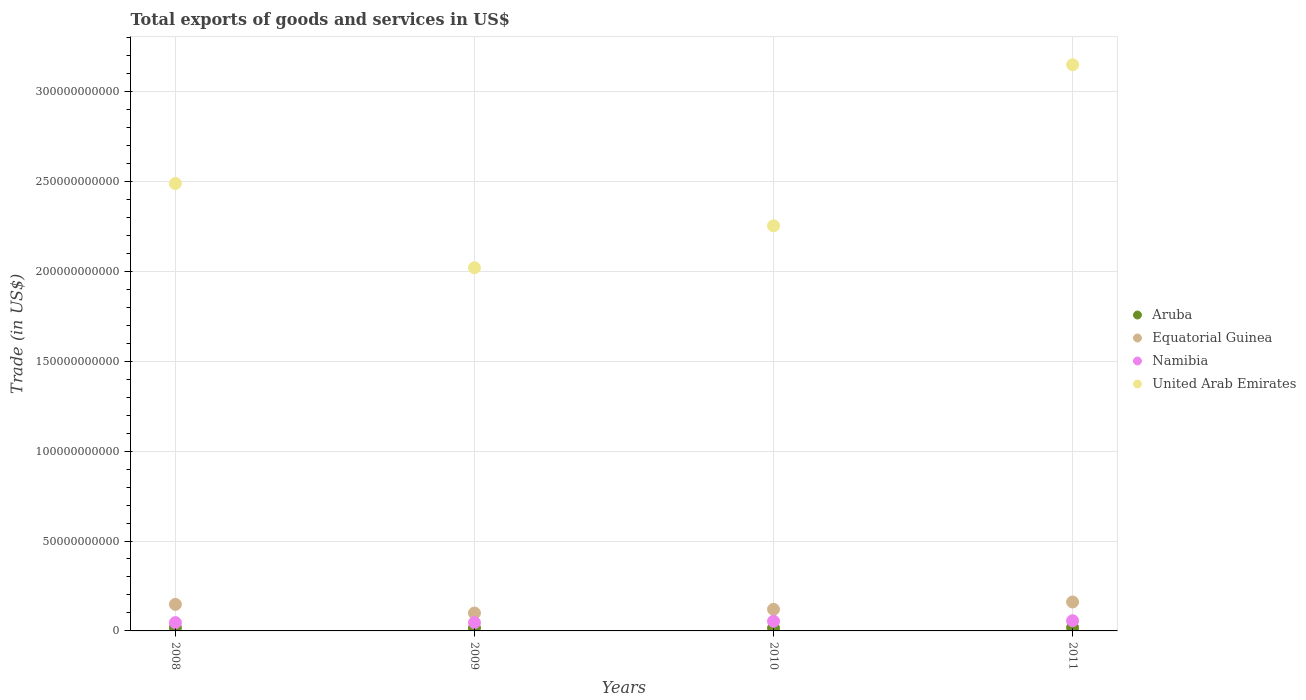What is the total exports of goods and services in Equatorial Guinea in 2010?
Your answer should be compact. 1.20e+1. Across all years, what is the maximum total exports of goods and services in Namibia?
Provide a succinct answer. 5.65e+09. Across all years, what is the minimum total exports of goods and services in Equatorial Guinea?
Provide a succinct answer. 9.96e+09. In which year was the total exports of goods and services in United Arab Emirates maximum?
Provide a succinct answer. 2011. What is the total total exports of goods and services in Namibia in the graph?
Your answer should be very brief. 2.03e+1. What is the difference between the total exports of goods and services in Equatorial Guinea in 2009 and that in 2011?
Offer a terse response. -6.13e+09. What is the difference between the total exports of goods and services in Aruba in 2011 and the total exports of goods and services in Namibia in 2008?
Your response must be concise. -2.78e+09. What is the average total exports of goods and services in United Arab Emirates per year?
Your response must be concise. 2.48e+11. In the year 2009, what is the difference between the total exports of goods and services in Equatorial Guinea and total exports of goods and services in United Arab Emirates?
Give a very brief answer. -1.92e+11. In how many years, is the total exports of goods and services in Equatorial Guinea greater than 90000000000 US$?
Your answer should be compact. 0. What is the ratio of the total exports of goods and services in Equatorial Guinea in 2009 to that in 2010?
Ensure brevity in your answer.  0.83. What is the difference between the highest and the second highest total exports of goods and services in Equatorial Guinea?
Offer a very short reply. 1.32e+09. What is the difference between the highest and the lowest total exports of goods and services in United Arab Emirates?
Offer a very short reply. 1.13e+11. In how many years, is the total exports of goods and services in Aruba greater than the average total exports of goods and services in Aruba taken over all years?
Offer a terse response. 2. Is it the case that in every year, the sum of the total exports of goods and services in Aruba and total exports of goods and services in United Arab Emirates  is greater than the total exports of goods and services in Equatorial Guinea?
Provide a succinct answer. Yes. Does the total exports of goods and services in United Arab Emirates monotonically increase over the years?
Offer a very short reply. No. Is the total exports of goods and services in United Arab Emirates strictly less than the total exports of goods and services in Equatorial Guinea over the years?
Make the answer very short. No. What is the difference between two consecutive major ticks on the Y-axis?
Keep it short and to the point. 5.00e+1. Does the graph contain any zero values?
Your response must be concise. No. Does the graph contain grids?
Provide a short and direct response. Yes. How many legend labels are there?
Ensure brevity in your answer.  4. How are the legend labels stacked?
Offer a terse response. Vertical. What is the title of the graph?
Provide a short and direct response. Total exports of goods and services in US$. What is the label or title of the Y-axis?
Offer a terse response. Trade (in US$). What is the Trade (in US$) of Aruba in 2008?
Offer a very short reply. 1.85e+09. What is the Trade (in US$) in Equatorial Guinea in 2008?
Your answer should be very brief. 1.48e+1. What is the Trade (in US$) of Namibia in 2008?
Provide a short and direct response. 4.61e+09. What is the Trade (in US$) in United Arab Emirates in 2008?
Provide a short and direct response. 2.49e+11. What is the Trade (in US$) of Aruba in 2009?
Provide a short and direct response. 1.59e+09. What is the Trade (in US$) in Equatorial Guinea in 2009?
Your response must be concise. 9.96e+09. What is the Trade (in US$) in Namibia in 2009?
Provide a short and direct response. 4.65e+09. What is the Trade (in US$) in United Arab Emirates in 2009?
Make the answer very short. 2.02e+11. What is the Trade (in US$) of Aruba in 2010?
Provide a succinct answer. 1.52e+09. What is the Trade (in US$) in Equatorial Guinea in 2010?
Provide a short and direct response. 1.20e+1. What is the Trade (in US$) of Namibia in 2010?
Offer a very short reply. 5.39e+09. What is the Trade (in US$) in United Arab Emirates in 2010?
Give a very brief answer. 2.25e+11. What is the Trade (in US$) of Aruba in 2011?
Keep it short and to the point. 1.83e+09. What is the Trade (in US$) in Equatorial Guinea in 2011?
Ensure brevity in your answer.  1.61e+1. What is the Trade (in US$) in Namibia in 2011?
Your response must be concise. 5.65e+09. What is the Trade (in US$) in United Arab Emirates in 2011?
Give a very brief answer. 3.15e+11. Across all years, what is the maximum Trade (in US$) in Aruba?
Offer a very short reply. 1.85e+09. Across all years, what is the maximum Trade (in US$) of Equatorial Guinea?
Your response must be concise. 1.61e+1. Across all years, what is the maximum Trade (in US$) of Namibia?
Give a very brief answer. 5.65e+09. Across all years, what is the maximum Trade (in US$) of United Arab Emirates?
Ensure brevity in your answer.  3.15e+11. Across all years, what is the minimum Trade (in US$) of Aruba?
Give a very brief answer. 1.52e+09. Across all years, what is the minimum Trade (in US$) in Equatorial Guinea?
Your answer should be compact. 9.96e+09. Across all years, what is the minimum Trade (in US$) of Namibia?
Keep it short and to the point. 4.61e+09. Across all years, what is the minimum Trade (in US$) in United Arab Emirates?
Offer a terse response. 2.02e+11. What is the total Trade (in US$) in Aruba in the graph?
Keep it short and to the point. 6.79e+09. What is the total Trade (in US$) of Equatorial Guinea in the graph?
Provide a succinct answer. 5.28e+1. What is the total Trade (in US$) of Namibia in the graph?
Offer a terse response. 2.03e+1. What is the total Trade (in US$) of United Arab Emirates in the graph?
Keep it short and to the point. 9.91e+11. What is the difference between the Trade (in US$) of Aruba in 2008 and that in 2009?
Make the answer very short. 2.56e+08. What is the difference between the Trade (in US$) of Equatorial Guinea in 2008 and that in 2009?
Offer a very short reply. 4.81e+09. What is the difference between the Trade (in US$) in Namibia in 2008 and that in 2009?
Provide a short and direct response. -3.35e+07. What is the difference between the Trade (in US$) of United Arab Emirates in 2008 and that in 2009?
Offer a terse response. 4.68e+1. What is the difference between the Trade (in US$) of Aruba in 2008 and that in 2010?
Offer a very short reply. 3.32e+08. What is the difference between the Trade (in US$) in Equatorial Guinea in 2008 and that in 2010?
Your response must be concise. 2.75e+09. What is the difference between the Trade (in US$) of Namibia in 2008 and that in 2010?
Your answer should be very brief. -7.75e+08. What is the difference between the Trade (in US$) in United Arab Emirates in 2008 and that in 2010?
Your answer should be compact. 2.35e+1. What is the difference between the Trade (in US$) of Aruba in 2008 and that in 2011?
Provide a succinct answer. 2.09e+07. What is the difference between the Trade (in US$) of Equatorial Guinea in 2008 and that in 2011?
Keep it short and to the point. -1.32e+09. What is the difference between the Trade (in US$) in Namibia in 2008 and that in 2011?
Your response must be concise. -1.04e+09. What is the difference between the Trade (in US$) of United Arab Emirates in 2008 and that in 2011?
Make the answer very short. -6.60e+1. What is the difference between the Trade (in US$) in Aruba in 2009 and that in 2010?
Your answer should be compact. 7.63e+07. What is the difference between the Trade (in US$) in Equatorial Guinea in 2009 and that in 2010?
Keep it short and to the point. -2.06e+09. What is the difference between the Trade (in US$) of Namibia in 2009 and that in 2010?
Keep it short and to the point. -7.42e+08. What is the difference between the Trade (in US$) of United Arab Emirates in 2009 and that in 2010?
Your answer should be compact. -2.33e+1. What is the difference between the Trade (in US$) of Aruba in 2009 and that in 2011?
Your answer should be very brief. -2.35e+08. What is the difference between the Trade (in US$) of Equatorial Guinea in 2009 and that in 2011?
Ensure brevity in your answer.  -6.13e+09. What is the difference between the Trade (in US$) of Namibia in 2009 and that in 2011?
Offer a very short reply. -1.00e+09. What is the difference between the Trade (in US$) in United Arab Emirates in 2009 and that in 2011?
Keep it short and to the point. -1.13e+11. What is the difference between the Trade (in US$) of Aruba in 2010 and that in 2011?
Provide a succinct answer. -3.11e+08. What is the difference between the Trade (in US$) of Equatorial Guinea in 2010 and that in 2011?
Provide a short and direct response. -4.07e+09. What is the difference between the Trade (in US$) in Namibia in 2010 and that in 2011?
Your response must be concise. -2.62e+08. What is the difference between the Trade (in US$) in United Arab Emirates in 2010 and that in 2011?
Keep it short and to the point. -8.96e+1. What is the difference between the Trade (in US$) in Aruba in 2008 and the Trade (in US$) in Equatorial Guinea in 2009?
Give a very brief answer. -8.11e+09. What is the difference between the Trade (in US$) in Aruba in 2008 and the Trade (in US$) in Namibia in 2009?
Your answer should be very brief. -2.80e+09. What is the difference between the Trade (in US$) in Aruba in 2008 and the Trade (in US$) in United Arab Emirates in 2009?
Offer a terse response. -2.00e+11. What is the difference between the Trade (in US$) of Equatorial Guinea in 2008 and the Trade (in US$) of Namibia in 2009?
Provide a short and direct response. 1.01e+1. What is the difference between the Trade (in US$) of Equatorial Guinea in 2008 and the Trade (in US$) of United Arab Emirates in 2009?
Your response must be concise. -1.87e+11. What is the difference between the Trade (in US$) in Namibia in 2008 and the Trade (in US$) in United Arab Emirates in 2009?
Make the answer very short. -1.97e+11. What is the difference between the Trade (in US$) of Aruba in 2008 and the Trade (in US$) of Equatorial Guinea in 2010?
Your answer should be very brief. -1.02e+1. What is the difference between the Trade (in US$) of Aruba in 2008 and the Trade (in US$) of Namibia in 2010?
Make the answer very short. -3.54e+09. What is the difference between the Trade (in US$) of Aruba in 2008 and the Trade (in US$) of United Arab Emirates in 2010?
Give a very brief answer. -2.23e+11. What is the difference between the Trade (in US$) in Equatorial Guinea in 2008 and the Trade (in US$) in Namibia in 2010?
Offer a very short reply. 9.38e+09. What is the difference between the Trade (in US$) in Equatorial Guinea in 2008 and the Trade (in US$) in United Arab Emirates in 2010?
Offer a terse response. -2.11e+11. What is the difference between the Trade (in US$) in Namibia in 2008 and the Trade (in US$) in United Arab Emirates in 2010?
Your answer should be very brief. -2.21e+11. What is the difference between the Trade (in US$) in Aruba in 2008 and the Trade (in US$) in Equatorial Guinea in 2011?
Give a very brief answer. -1.42e+1. What is the difference between the Trade (in US$) of Aruba in 2008 and the Trade (in US$) of Namibia in 2011?
Your answer should be very brief. -3.80e+09. What is the difference between the Trade (in US$) of Aruba in 2008 and the Trade (in US$) of United Arab Emirates in 2011?
Keep it short and to the point. -3.13e+11. What is the difference between the Trade (in US$) in Equatorial Guinea in 2008 and the Trade (in US$) in Namibia in 2011?
Offer a very short reply. 9.12e+09. What is the difference between the Trade (in US$) in Equatorial Guinea in 2008 and the Trade (in US$) in United Arab Emirates in 2011?
Provide a short and direct response. -3.00e+11. What is the difference between the Trade (in US$) of Namibia in 2008 and the Trade (in US$) of United Arab Emirates in 2011?
Make the answer very short. -3.10e+11. What is the difference between the Trade (in US$) in Aruba in 2009 and the Trade (in US$) in Equatorial Guinea in 2010?
Offer a very short reply. -1.04e+1. What is the difference between the Trade (in US$) of Aruba in 2009 and the Trade (in US$) of Namibia in 2010?
Provide a short and direct response. -3.79e+09. What is the difference between the Trade (in US$) of Aruba in 2009 and the Trade (in US$) of United Arab Emirates in 2010?
Offer a very short reply. -2.24e+11. What is the difference between the Trade (in US$) of Equatorial Guinea in 2009 and the Trade (in US$) of Namibia in 2010?
Provide a succinct answer. 4.57e+09. What is the difference between the Trade (in US$) in Equatorial Guinea in 2009 and the Trade (in US$) in United Arab Emirates in 2010?
Provide a succinct answer. -2.15e+11. What is the difference between the Trade (in US$) of Namibia in 2009 and the Trade (in US$) of United Arab Emirates in 2010?
Ensure brevity in your answer.  -2.21e+11. What is the difference between the Trade (in US$) of Aruba in 2009 and the Trade (in US$) of Equatorial Guinea in 2011?
Your answer should be very brief. -1.45e+1. What is the difference between the Trade (in US$) of Aruba in 2009 and the Trade (in US$) of Namibia in 2011?
Provide a short and direct response. -4.06e+09. What is the difference between the Trade (in US$) of Aruba in 2009 and the Trade (in US$) of United Arab Emirates in 2011?
Provide a succinct answer. -3.13e+11. What is the difference between the Trade (in US$) in Equatorial Guinea in 2009 and the Trade (in US$) in Namibia in 2011?
Offer a very short reply. 4.31e+09. What is the difference between the Trade (in US$) in Equatorial Guinea in 2009 and the Trade (in US$) in United Arab Emirates in 2011?
Provide a succinct answer. -3.05e+11. What is the difference between the Trade (in US$) of Namibia in 2009 and the Trade (in US$) of United Arab Emirates in 2011?
Give a very brief answer. -3.10e+11. What is the difference between the Trade (in US$) of Aruba in 2010 and the Trade (in US$) of Equatorial Guinea in 2011?
Offer a very short reply. -1.46e+1. What is the difference between the Trade (in US$) in Aruba in 2010 and the Trade (in US$) in Namibia in 2011?
Keep it short and to the point. -4.13e+09. What is the difference between the Trade (in US$) in Aruba in 2010 and the Trade (in US$) in United Arab Emirates in 2011?
Give a very brief answer. -3.13e+11. What is the difference between the Trade (in US$) of Equatorial Guinea in 2010 and the Trade (in US$) of Namibia in 2011?
Provide a short and direct response. 6.37e+09. What is the difference between the Trade (in US$) of Equatorial Guinea in 2010 and the Trade (in US$) of United Arab Emirates in 2011?
Offer a very short reply. -3.03e+11. What is the difference between the Trade (in US$) in Namibia in 2010 and the Trade (in US$) in United Arab Emirates in 2011?
Make the answer very short. -3.09e+11. What is the average Trade (in US$) of Aruba per year?
Make the answer very short. 1.70e+09. What is the average Trade (in US$) in Equatorial Guinea per year?
Give a very brief answer. 1.32e+1. What is the average Trade (in US$) of Namibia per year?
Give a very brief answer. 5.07e+09. What is the average Trade (in US$) of United Arab Emirates per year?
Give a very brief answer. 2.48e+11. In the year 2008, what is the difference between the Trade (in US$) of Aruba and Trade (in US$) of Equatorial Guinea?
Give a very brief answer. -1.29e+1. In the year 2008, what is the difference between the Trade (in US$) in Aruba and Trade (in US$) in Namibia?
Ensure brevity in your answer.  -2.76e+09. In the year 2008, what is the difference between the Trade (in US$) of Aruba and Trade (in US$) of United Arab Emirates?
Ensure brevity in your answer.  -2.47e+11. In the year 2008, what is the difference between the Trade (in US$) in Equatorial Guinea and Trade (in US$) in Namibia?
Your answer should be compact. 1.02e+1. In the year 2008, what is the difference between the Trade (in US$) of Equatorial Guinea and Trade (in US$) of United Arab Emirates?
Your answer should be very brief. -2.34e+11. In the year 2008, what is the difference between the Trade (in US$) in Namibia and Trade (in US$) in United Arab Emirates?
Keep it short and to the point. -2.44e+11. In the year 2009, what is the difference between the Trade (in US$) of Aruba and Trade (in US$) of Equatorial Guinea?
Make the answer very short. -8.36e+09. In the year 2009, what is the difference between the Trade (in US$) of Aruba and Trade (in US$) of Namibia?
Provide a short and direct response. -3.05e+09. In the year 2009, what is the difference between the Trade (in US$) of Aruba and Trade (in US$) of United Arab Emirates?
Your response must be concise. -2.00e+11. In the year 2009, what is the difference between the Trade (in US$) in Equatorial Guinea and Trade (in US$) in Namibia?
Your response must be concise. 5.31e+09. In the year 2009, what is the difference between the Trade (in US$) in Equatorial Guinea and Trade (in US$) in United Arab Emirates?
Offer a very short reply. -1.92e+11. In the year 2009, what is the difference between the Trade (in US$) of Namibia and Trade (in US$) of United Arab Emirates?
Offer a terse response. -1.97e+11. In the year 2010, what is the difference between the Trade (in US$) of Aruba and Trade (in US$) of Equatorial Guinea?
Provide a succinct answer. -1.05e+1. In the year 2010, what is the difference between the Trade (in US$) in Aruba and Trade (in US$) in Namibia?
Make the answer very short. -3.87e+09. In the year 2010, what is the difference between the Trade (in US$) of Aruba and Trade (in US$) of United Arab Emirates?
Provide a short and direct response. -2.24e+11. In the year 2010, what is the difference between the Trade (in US$) of Equatorial Guinea and Trade (in US$) of Namibia?
Make the answer very short. 6.63e+09. In the year 2010, what is the difference between the Trade (in US$) of Equatorial Guinea and Trade (in US$) of United Arab Emirates?
Your answer should be compact. -2.13e+11. In the year 2010, what is the difference between the Trade (in US$) in Namibia and Trade (in US$) in United Arab Emirates?
Keep it short and to the point. -2.20e+11. In the year 2011, what is the difference between the Trade (in US$) of Aruba and Trade (in US$) of Equatorial Guinea?
Your answer should be compact. -1.43e+1. In the year 2011, what is the difference between the Trade (in US$) in Aruba and Trade (in US$) in Namibia?
Your answer should be very brief. -3.82e+09. In the year 2011, what is the difference between the Trade (in US$) of Aruba and Trade (in US$) of United Arab Emirates?
Provide a short and direct response. -3.13e+11. In the year 2011, what is the difference between the Trade (in US$) in Equatorial Guinea and Trade (in US$) in Namibia?
Provide a short and direct response. 1.04e+1. In the year 2011, what is the difference between the Trade (in US$) of Equatorial Guinea and Trade (in US$) of United Arab Emirates?
Provide a short and direct response. -2.99e+11. In the year 2011, what is the difference between the Trade (in US$) in Namibia and Trade (in US$) in United Arab Emirates?
Offer a very short reply. -3.09e+11. What is the ratio of the Trade (in US$) in Aruba in 2008 to that in 2009?
Your response must be concise. 1.16. What is the ratio of the Trade (in US$) of Equatorial Guinea in 2008 to that in 2009?
Make the answer very short. 1.48. What is the ratio of the Trade (in US$) of United Arab Emirates in 2008 to that in 2009?
Ensure brevity in your answer.  1.23. What is the ratio of the Trade (in US$) in Aruba in 2008 to that in 2010?
Offer a very short reply. 1.22. What is the ratio of the Trade (in US$) in Equatorial Guinea in 2008 to that in 2010?
Provide a succinct answer. 1.23. What is the ratio of the Trade (in US$) of Namibia in 2008 to that in 2010?
Your answer should be compact. 0.86. What is the ratio of the Trade (in US$) in United Arab Emirates in 2008 to that in 2010?
Offer a terse response. 1.1. What is the ratio of the Trade (in US$) in Aruba in 2008 to that in 2011?
Keep it short and to the point. 1.01. What is the ratio of the Trade (in US$) in Equatorial Guinea in 2008 to that in 2011?
Offer a very short reply. 0.92. What is the ratio of the Trade (in US$) in Namibia in 2008 to that in 2011?
Give a very brief answer. 0.82. What is the ratio of the Trade (in US$) of United Arab Emirates in 2008 to that in 2011?
Your answer should be compact. 0.79. What is the ratio of the Trade (in US$) in Aruba in 2009 to that in 2010?
Keep it short and to the point. 1.05. What is the ratio of the Trade (in US$) in Equatorial Guinea in 2009 to that in 2010?
Give a very brief answer. 0.83. What is the ratio of the Trade (in US$) in Namibia in 2009 to that in 2010?
Provide a short and direct response. 0.86. What is the ratio of the Trade (in US$) in United Arab Emirates in 2009 to that in 2010?
Provide a short and direct response. 0.9. What is the ratio of the Trade (in US$) in Aruba in 2009 to that in 2011?
Give a very brief answer. 0.87. What is the ratio of the Trade (in US$) in Equatorial Guinea in 2009 to that in 2011?
Offer a very short reply. 0.62. What is the ratio of the Trade (in US$) of Namibia in 2009 to that in 2011?
Offer a terse response. 0.82. What is the ratio of the Trade (in US$) in United Arab Emirates in 2009 to that in 2011?
Keep it short and to the point. 0.64. What is the ratio of the Trade (in US$) of Aruba in 2010 to that in 2011?
Give a very brief answer. 0.83. What is the ratio of the Trade (in US$) in Equatorial Guinea in 2010 to that in 2011?
Your answer should be very brief. 0.75. What is the ratio of the Trade (in US$) in Namibia in 2010 to that in 2011?
Your answer should be compact. 0.95. What is the ratio of the Trade (in US$) in United Arab Emirates in 2010 to that in 2011?
Offer a terse response. 0.72. What is the difference between the highest and the second highest Trade (in US$) of Aruba?
Keep it short and to the point. 2.09e+07. What is the difference between the highest and the second highest Trade (in US$) of Equatorial Guinea?
Your response must be concise. 1.32e+09. What is the difference between the highest and the second highest Trade (in US$) in Namibia?
Your response must be concise. 2.62e+08. What is the difference between the highest and the second highest Trade (in US$) in United Arab Emirates?
Offer a terse response. 6.60e+1. What is the difference between the highest and the lowest Trade (in US$) of Aruba?
Your answer should be very brief. 3.32e+08. What is the difference between the highest and the lowest Trade (in US$) of Equatorial Guinea?
Offer a very short reply. 6.13e+09. What is the difference between the highest and the lowest Trade (in US$) of Namibia?
Your answer should be compact. 1.04e+09. What is the difference between the highest and the lowest Trade (in US$) in United Arab Emirates?
Your response must be concise. 1.13e+11. 